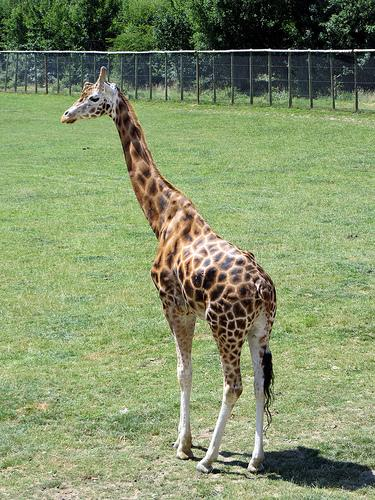What's the most prominent aspect in the scene, and what is its general condition? A giraffe with brown and white patches is the focal point, residing in a green grassy area enclosed with a fence. State what the subject is doing and what surrounds the subject. The giraffe is extending its neck in a fenced-off green grassy area, with trees in the background. Outline the key elements in the image, focusing on the primary subject and its surroundings. A giraffe with an extended neck stands in a fenced grassy field, with trees behind the fence and a few black and white wheels on the ground. Describe the image in one sentence, focusing on the main subject. A giraffe with a long neck is stretching amidst a fenced grassy pasture featuring a few trees and black and white wheels. List the major elements in the picture. Giraffe, extended neck, green grassy area, metal wire fence, trees, black and white wheels. Explain the scene that is unfolding in the picture. In this image, a giraffe with a long neck and legs is stretching its neck while standing in a fenced grassy pasture. Briefly describe the main action in the image, and the location it occurs in. A giraffe is lengthening its neck while standing in a green grassy pasture enclosed by a fence, with trees in the background. Mention the central object in the picture and its environment. A brown and white giraffe with an extended neck stands in a green grassy pasture surrounded by a metal wire fence and trees. Mention the most prominent animal in the picture and its environment. A giraffe with a long neck and brown and white patches stands amidst a grassy area enclosed by a metal wire fence. Convey the main idea of the image and what the primary subject is situated in. The image captures a brown and white giraffe with an outstretched neck, residing within a fenced grassy pasture. 